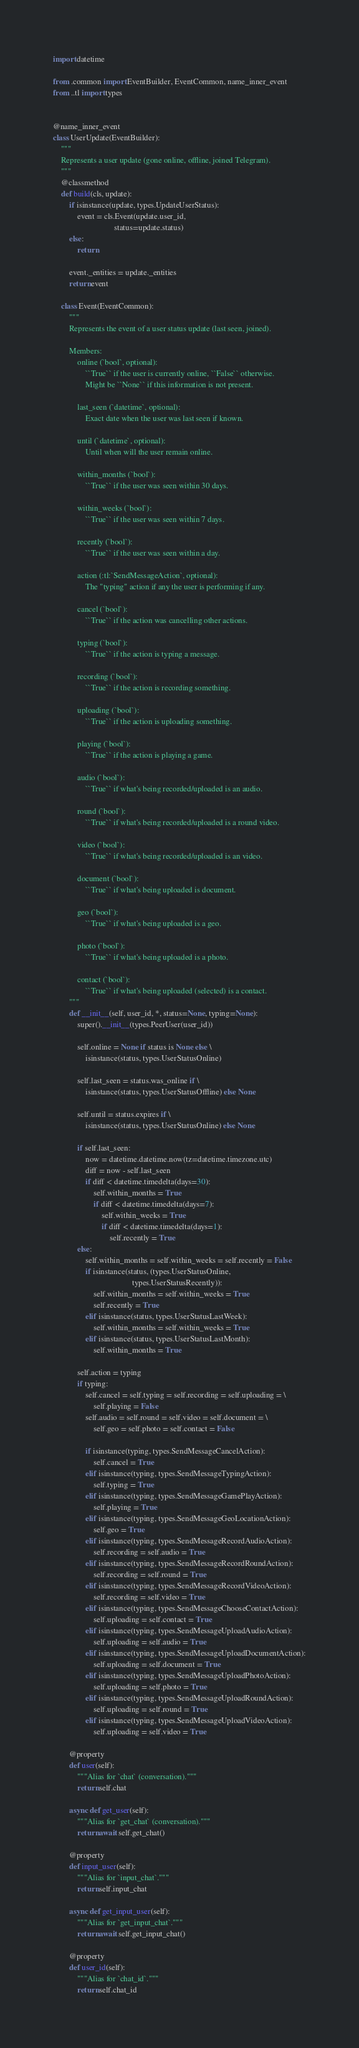Convert code to text. <code><loc_0><loc_0><loc_500><loc_500><_Python_>import datetime

from .common import EventBuilder, EventCommon, name_inner_event
from ..tl import types


@name_inner_event
class UserUpdate(EventBuilder):
    """
    Represents a user update (gone online, offline, joined Telegram).
    """
    @classmethod
    def build(cls, update):
        if isinstance(update, types.UpdateUserStatus):
            event = cls.Event(update.user_id,
                              status=update.status)
        else:
            return

        event._entities = update._entities
        return event

    class Event(EventCommon):
        """
        Represents the event of a user status update (last seen, joined).

        Members:
            online (`bool`, optional):
                ``True`` if the user is currently online, ``False`` otherwise.
                Might be ``None`` if this information is not present.

            last_seen (`datetime`, optional):
                Exact date when the user was last seen if known.

            until (`datetime`, optional):
                Until when will the user remain online.

            within_months (`bool`):
                ``True`` if the user was seen within 30 days.

            within_weeks (`bool`):
                ``True`` if the user was seen within 7 days.

            recently (`bool`):
                ``True`` if the user was seen within a day.

            action (:tl:`SendMessageAction`, optional):
                The "typing" action if any the user is performing if any.

            cancel (`bool`):
                ``True`` if the action was cancelling other actions.

            typing (`bool`):
                ``True`` if the action is typing a message.

            recording (`bool`):
                ``True`` if the action is recording something.

            uploading (`bool`):
                ``True`` if the action is uploading something.

            playing (`bool`):
                ``True`` if the action is playing a game.

            audio (`bool`):
                ``True`` if what's being recorded/uploaded is an audio.

            round (`bool`):
                ``True`` if what's being recorded/uploaded is a round video.

            video (`bool`):
                ``True`` if what's being recorded/uploaded is an video.

            document (`bool`):
                ``True`` if what's being uploaded is document.

            geo (`bool`):
                ``True`` if what's being uploaded is a geo.

            photo (`bool`):
                ``True`` if what's being uploaded is a photo.

            contact (`bool`):
                ``True`` if what's being uploaded (selected) is a contact.
        """
        def __init__(self, user_id, *, status=None, typing=None):
            super().__init__(types.PeerUser(user_id))

            self.online = None if status is None else \
                isinstance(status, types.UserStatusOnline)

            self.last_seen = status.was_online if \
                isinstance(status, types.UserStatusOffline) else None

            self.until = status.expires if \
                isinstance(status, types.UserStatusOnline) else None

            if self.last_seen:
                now = datetime.datetime.now(tz=datetime.timezone.utc)
                diff = now - self.last_seen
                if diff < datetime.timedelta(days=30):
                    self.within_months = True
                    if diff < datetime.timedelta(days=7):
                        self.within_weeks = True
                        if diff < datetime.timedelta(days=1):
                            self.recently = True
            else:
                self.within_months = self.within_weeks = self.recently = False
                if isinstance(status, (types.UserStatusOnline,
                                       types.UserStatusRecently)):
                    self.within_months = self.within_weeks = True
                    self.recently = True
                elif isinstance(status, types.UserStatusLastWeek):
                    self.within_months = self.within_weeks = True
                elif isinstance(status, types.UserStatusLastMonth):
                    self.within_months = True

            self.action = typing
            if typing:
                self.cancel = self.typing = self.recording = self.uploading = \
                    self.playing = False
                self.audio = self.round = self.video = self.document = \
                    self.geo = self.photo = self.contact = False

                if isinstance(typing, types.SendMessageCancelAction):
                    self.cancel = True
                elif isinstance(typing, types.SendMessageTypingAction):
                    self.typing = True
                elif isinstance(typing, types.SendMessageGamePlayAction):
                    self.playing = True
                elif isinstance(typing, types.SendMessageGeoLocationAction):
                    self.geo = True
                elif isinstance(typing, types.SendMessageRecordAudioAction):
                    self.recording = self.audio = True
                elif isinstance(typing, types.SendMessageRecordRoundAction):
                    self.recording = self.round = True
                elif isinstance(typing, types.SendMessageRecordVideoAction):
                    self.recording = self.video = True
                elif isinstance(typing, types.SendMessageChooseContactAction):
                    self.uploading = self.contact = True
                elif isinstance(typing, types.SendMessageUploadAudioAction):
                    self.uploading = self.audio = True
                elif isinstance(typing, types.SendMessageUploadDocumentAction):
                    self.uploading = self.document = True
                elif isinstance(typing, types.SendMessageUploadPhotoAction):
                    self.uploading = self.photo = True
                elif isinstance(typing, types.SendMessageUploadRoundAction):
                    self.uploading = self.round = True
                elif isinstance(typing, types.SendMessageUploadVideoAction):
                    self.uploading = self.video = True

        @property
        def user(self):
            """Alias for `chat` (conversation)."""
            return self.chat

        async def get_user(self):
            """Alias for `get_chat` (conversation)."""
            return await self.get_chat()

        @property
        def input_user(self):
            """Alias for `input_chat`."""
            return self.input_chat

        async def get_input_user(self):
            """Alias for `get_input_chat`."""
            return await self.get_input_chat()

        @property
        def user_id(self):
            """Alias for `chat_id`."""
            return self.chat_id
</code> 